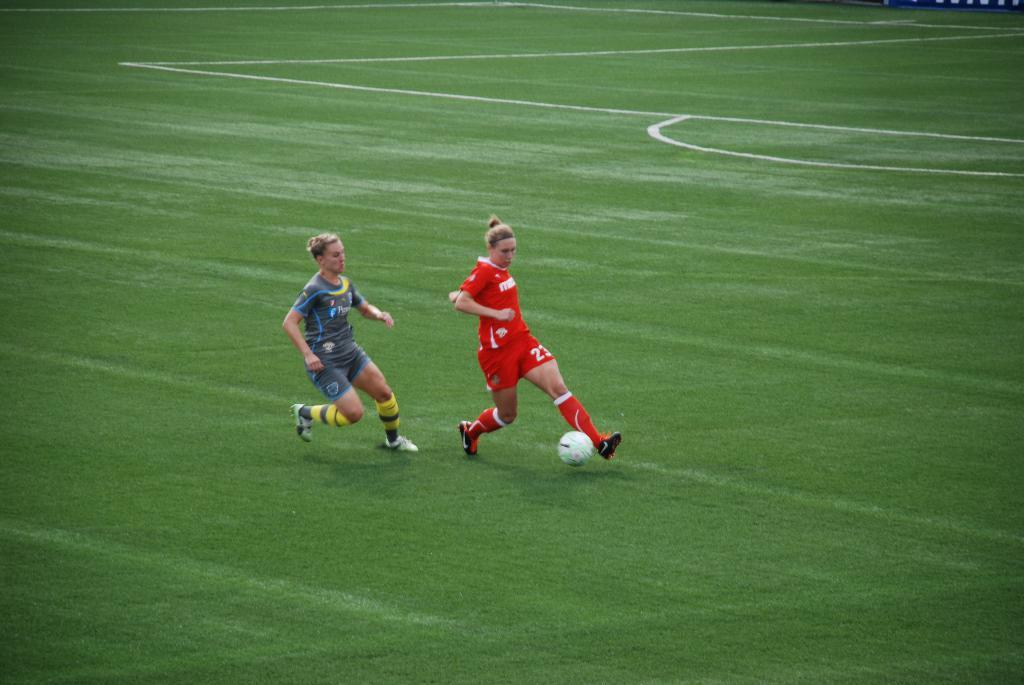<image>
Present a compact description of the photo's key features. A picture of 2 soccer players, one who has the number 23 on her shorts 